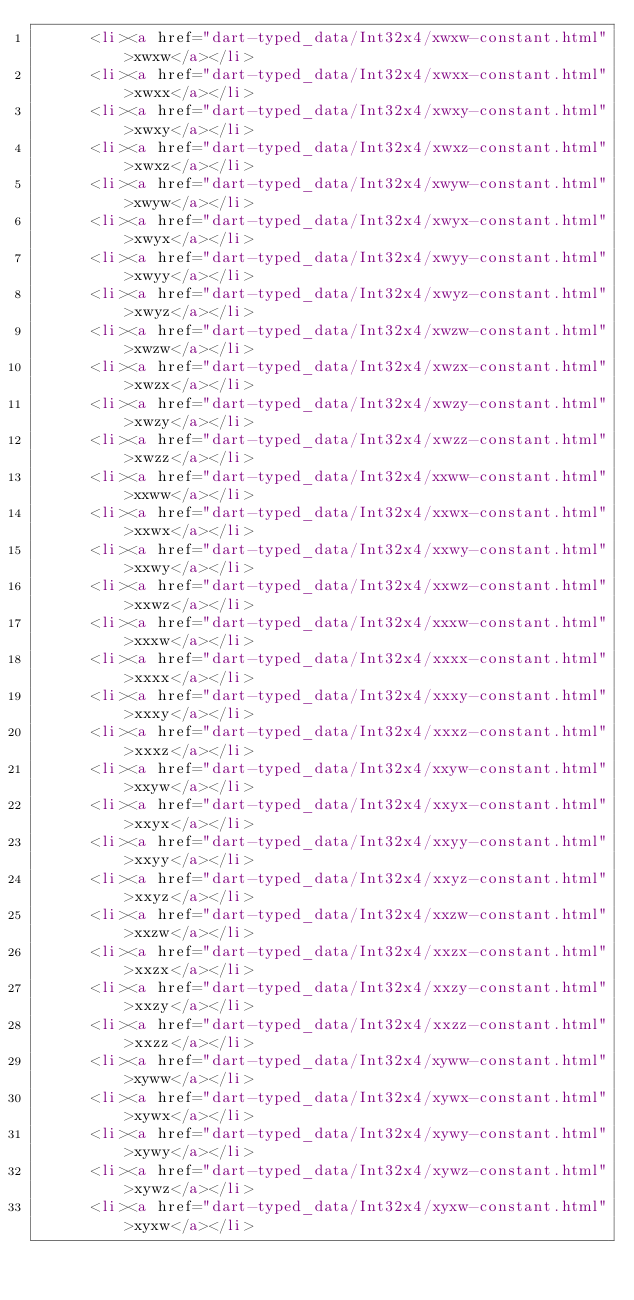Convert code to text. <code><loc_0><loc_0><loc_500><loc_500><_HTML_>      <li><a href="dart-typed_data/Int32x4/xwxw-constant.html">xwxw</a></li>
      <li><a href="dart-typed_data/Int32x4/xwxx-constant.html">xwxx</a></li>
      <li><a href="dart-typed_data/Int32x4/xwxy-constant.html">xwxy</a></li>
      <li><a href="dart-typed_data/Int32x4/xwxz-constant.html">xwxz</a></li>
      <li><a href="dart-typed_data/Int32x4/xwyw-constant.html">xwyw</a></li>
      <li><a href="dart-typed_data/Int32x4/xwyx-constant.html">xwyx</a></li>
      <li><a href="dart-typed_data/Int32x4/xwyy-constant.html">xwyy</a></li>
      <li><a href="dart-typed_data/Int32x4/xwyz-constant.html">xwyz</a></li>
      <li><a href="dart-typed_data/Int32x4/xwzw-constant.html">xwzw</a></li>
      <li><a href="dart-typed_data/Int32x4/xwzx-constant.html">xwzx</a></li>
      <li><a href="dart-typed_data/Int32x4/xwzy-constant.html">xwzy</a></li>
      <li><a href="dart-typed_data/Int32x4/xwzz-constant.html">xwzz</a></li>
      <li><a href="dart-typed_data/Int32x4/xxww-constant.html">xxww</a></li>
      <li><a href="dart-typed_data/Int32x4/xxwx-constant.html">xxwx</a></li>
      <li><a href="dart-typed_data/Int32x4/xxwy-constant.html">xxwy</a></li>
      <li><a href="dart-typed_data/Int32x4/xxwz-constant.html">xxwz</a></li>
      <li><a href="dart-typed_data/Int32x4/xxxw-constant.html">xxxw</a></li>
      <li><a href="dart-typed_data/Int32x4/xxxx-constant.html">xxxx</a></li>
      <li><a href="dart-typed_data/Int32x4/xxxy-constant.html">xxxy</a></li>
      <li><a href="dart-typed_data/Int32x4/xxxz-constant.html">xxxz</a></li>
      <li><a href="dart-typed_data/Int32x4/xxyw-constant.html">xxyw</a></li>
      <li><a href="dart-typed_data/Int32x4/xxyx-constant.html">xxyx</a></li>
      <li><a href="dart-typed_data/Int32x4/xxyy-constant.html">xxyy</a></li>
      <li><a href="dart-typed_data/Int32x4/xxyz-constant.html">xxyz</a></li>
      <li><a href="dart-typed_data/Int32x4/xxzw-constant.html">xxzw</a></li>
      <li><a href="dart-typed_data/Int32x4/xxzx-constant.html">xxzx</a></li>
      <li><a href="dart-typed_data/Int32x4/xxzy-constant.html">xxzy</a></li>
      <li><a href="dart-typed_data/Int32x4/xxzz-constant.html">xxzz</a></li>
      <li><a href="dart-typed_data/Int32x4/xyww-constant.html">xyww</a></li>
      <li><a href="dart-typed_data/Int32x4/xywx-constant.html">xywx</a></li>
      <li><a href="dart-typed_data/Int32x4/xywy-constant.html">xywy</a></li>
      <li><a href="dart-typed_data/Int32x4/xywz-constant.html">xywz</a></li>
      <li><a href="dart-typed_data/Int32x4/xyxw-constant.html">xyxw</a></li></code> 